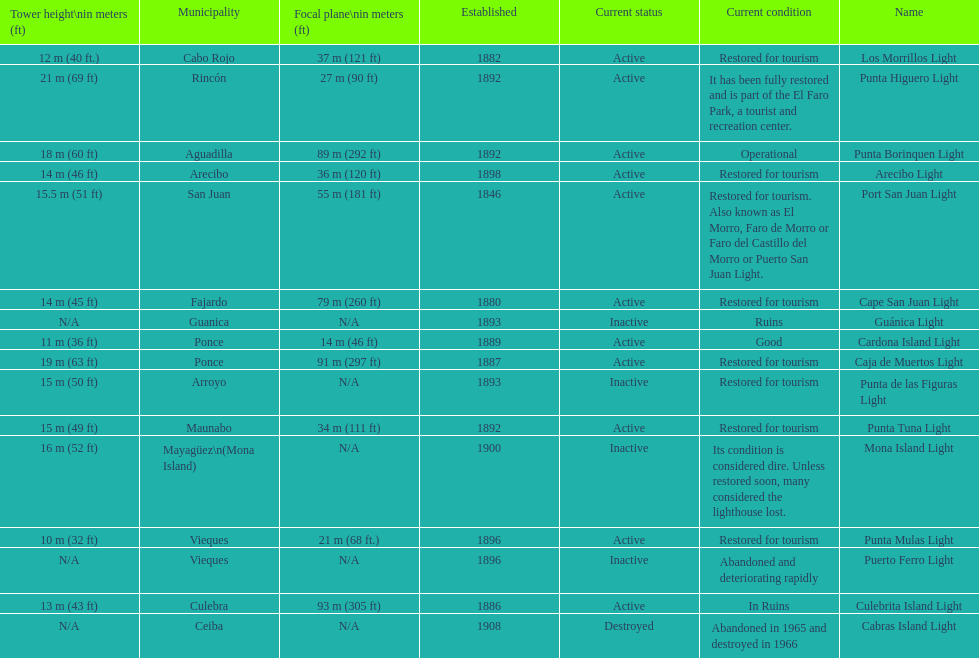How many towers are at least 18 meters tall? 3. 